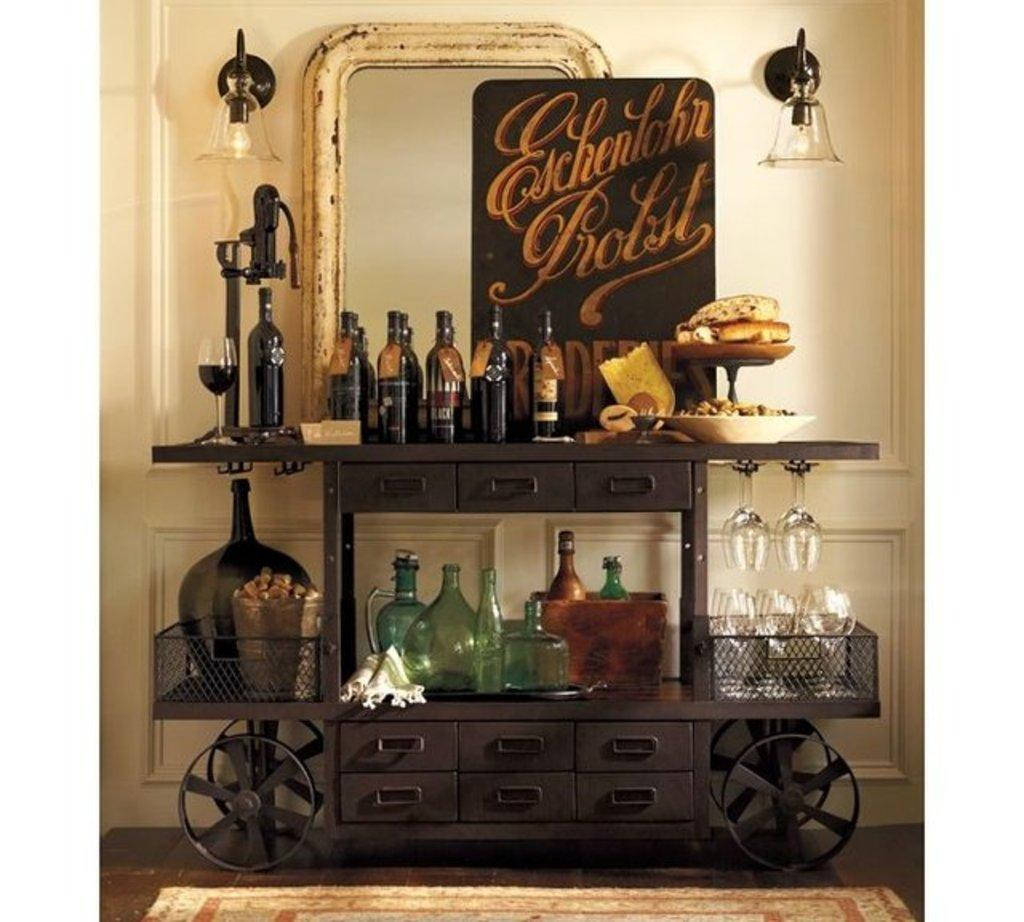<image>
Create a compact narrative representing the image presented. wooden wheeled cart with glasses and bottle with sign eschenlohr probst 